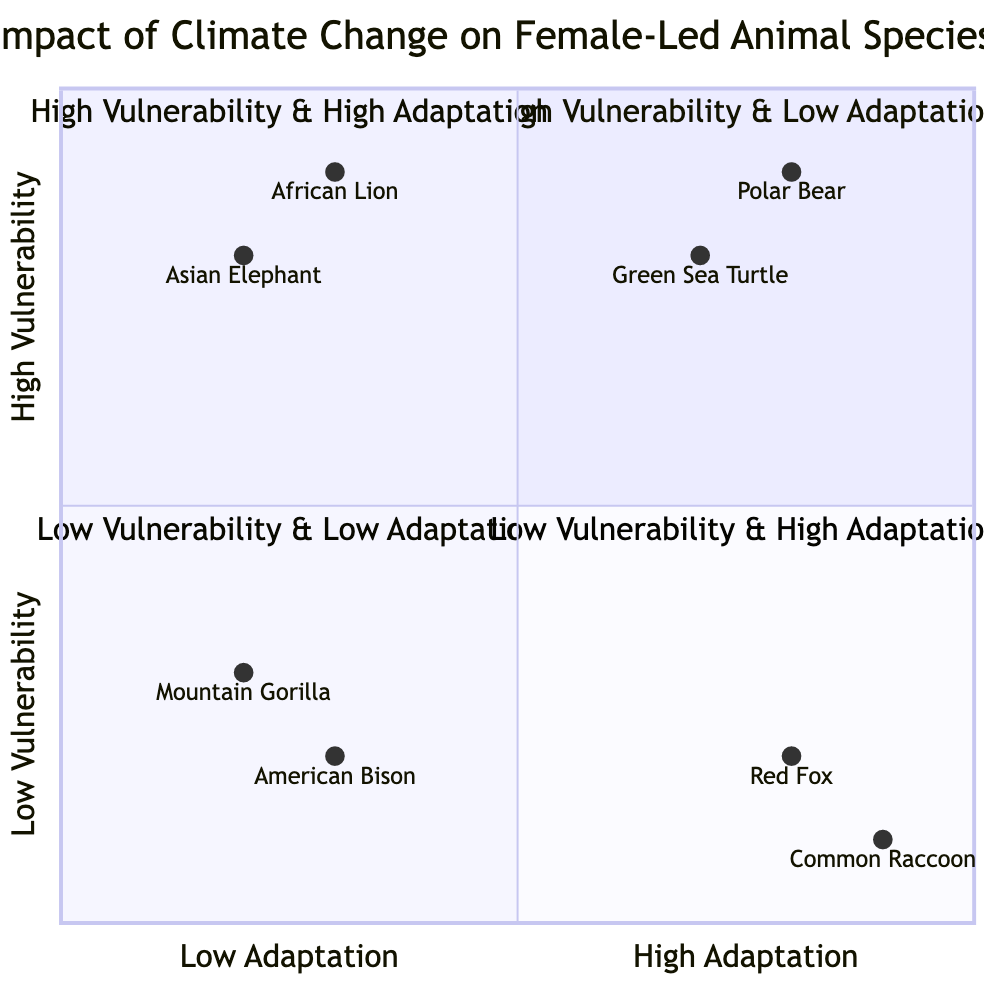What species is most vulnerable with low adaptation? The diagram indicates that the Asian Elephant and African Lion are classified in the "High Vulnerability & Low Adaptation" quadrant, representing the most vulnerable species with low adaptation strategies.
Answer: Asian Elephant and African Lion How many species are in the "Low Vulnerability & Low Adaptation" quadrant? From the diagram, there are two species listed in the "Low Vulnerability & Low Adaptation" quadrant, namely the American Bison and Mountain Gorilla.
Answer: 2 Which species has the highest adaptation strategy? The Polar Bear is placed in the "High Vulnerability & High Adaptation" quadrant and possesses multiple adaptation strategies, indicating it has the highest adaptation capability among species shown.
Answer: Polar Bear What adaptation strategy is shared between the Green Sea Turtle and Polar Bear? Both species, Green Sea Turtle and Polar Bear, show a capacity for changing behaviors in response to environmental shifts, which encompasses their adaptive strategies of seeking alternative locations and altering their hunting or nesting times respectively.
Answer: Seeking alternative habitats Are there more species with high vulnerability or low vulnerability? Comparing the quadrants, there are four species categorized under high vulnerability (two in "High Vulnerability & Low Adaptation" and two in "High Vulnerability & High Adaptation") against two species in the "Low Vulnerability" quadrants (one in "Low Vulnerability & Low Adaptation" and one in "Low Vulnerability & High Adaptation").
Answer: More species with high vulnerability What is the common factor among the species in the "Low Vulnerability & High Adaptation" quadrant? The species in the "Low Vulnerability & High Adaptation" quadrant, namely Red Fox and Common Raccoon, exhibit behavioral flexibility and adaptability to various environments, showcasing their resilience in changing circumstances.
Answer: Behavioral flexibility Which species faces increased human-wildlife conflicts due to climate change? According to the quadrant descriptions, the Asian Elephant encounters increased human-wildlife conflicts as one of the challenges due to climate change, placing it under high vulnerability.
Answer: Asian Elephant What is the adaptation strategy of the Common Raccoon? In the diagram, one of the adaptation strategies of the Common Raccoon is its highly opportunistic feeding behavior, which enables it to thrive in varying environments.
Answer: Highly opportunistic feeding behavior 